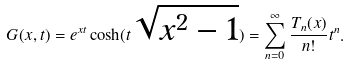<formula> <loc_0><loc_0><loc_500><loc_500>G ( x , t ) = e ^ { x t } \cosh ( t \sqrt { x ^ { 2 } - 1 } ) = \sum _ { n = 0 } ^ { \infty } \frac { T _ { n } ( x ) } { n ! } t ^ { n } .</formula> 